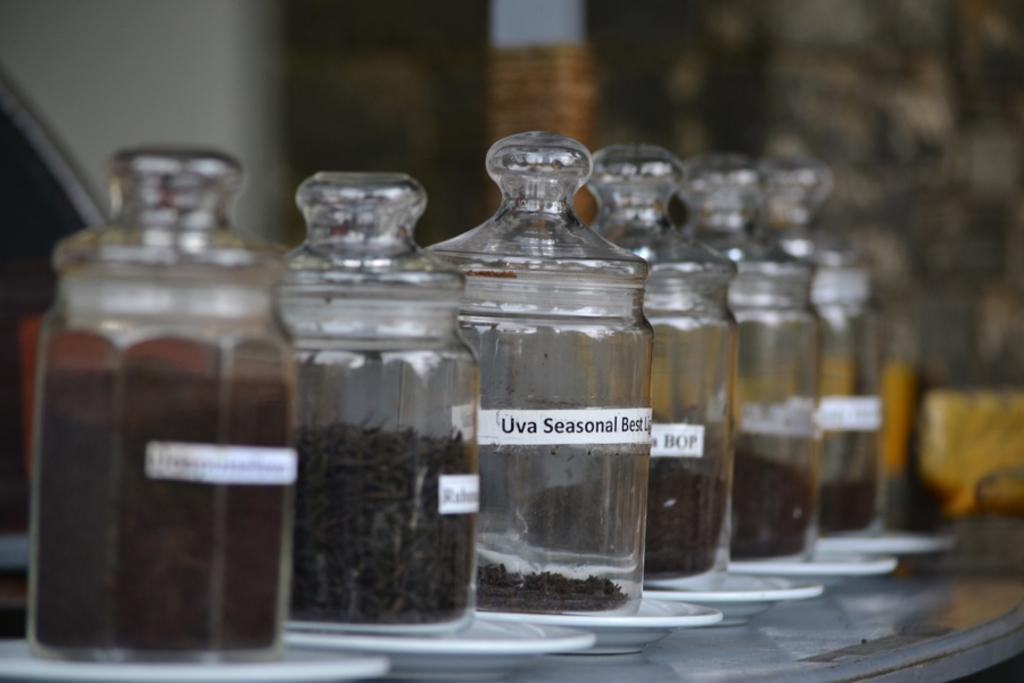<image>
Give a short and clear explanation of the subsequent image. Clear container with spices in them, one of which is Uva Seasonal Best. 